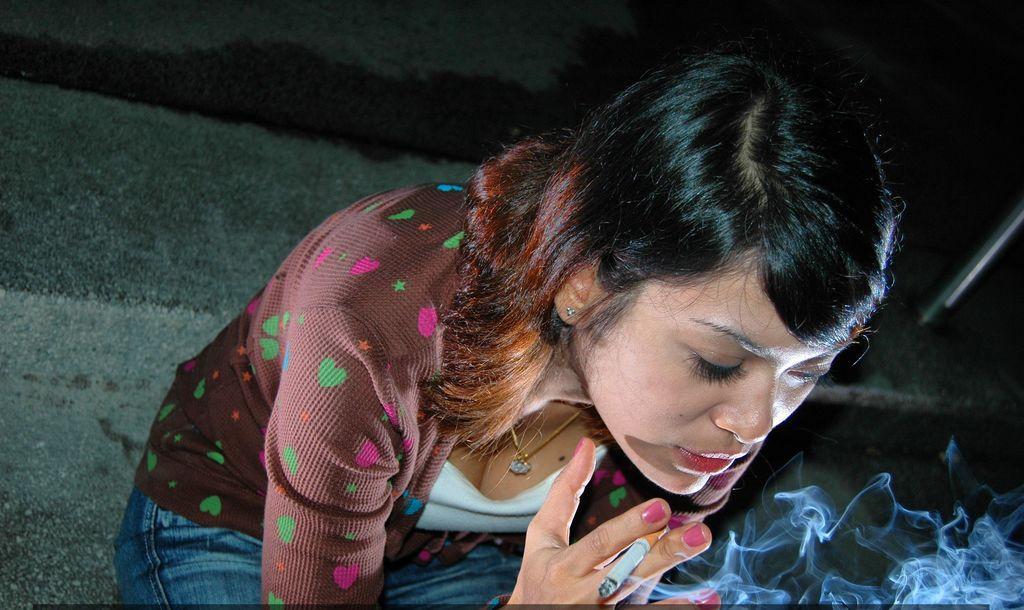Please provide a concise description of this image. In this image I can see a woman ,she holding a cigarette on her hand , there is a smoke visible at the bottom. 